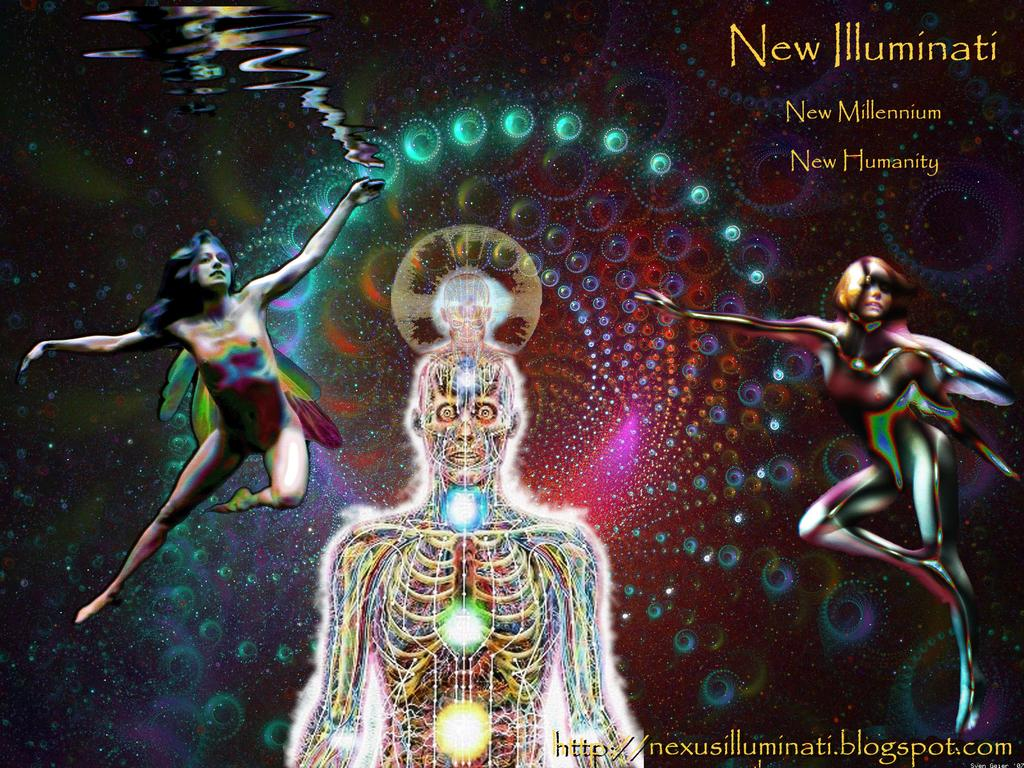<image>
Render a clear and concise summary of the photo. A colorful skeleton and two other human figures on a poster of New Illuminati. 